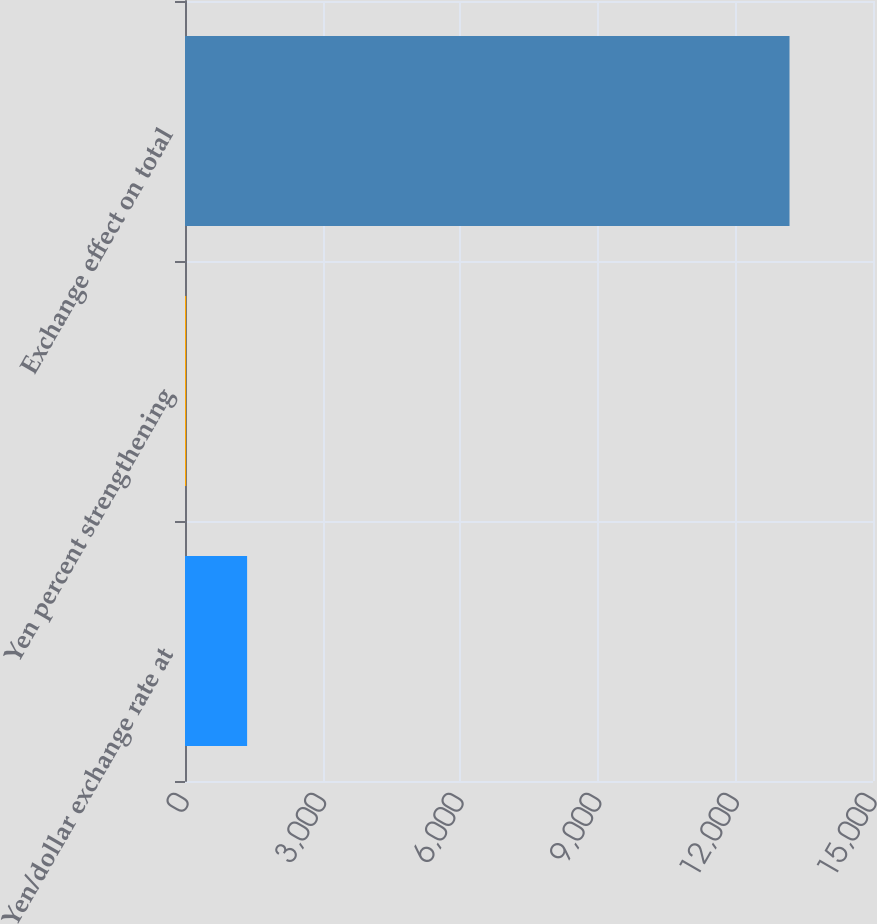Convert chart to OTSL. <chart><loc_0><loc_0><loc_500><loc_500><bar_chart><fcel>Yen/dollar exchange rate at<fcel>Yen percent strengthening<fcel>Exchange effect on total<nl><fcel>1354.06<fcel>25.4<fcel>13180<nl></chart> 